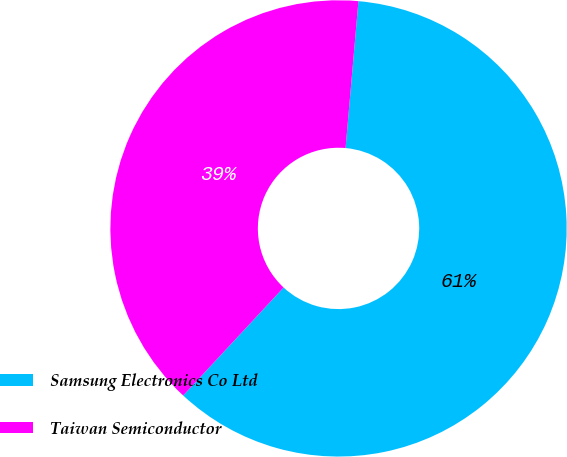<chart> <loc_0><loc_0><loc_500><loc_500><pie_chart><fcel>Samsung Electronics Co Ltd<fcel>Taiwan Semiconductor<nl><fcel>60.53%<fcel>39.47%<nl></chart> 